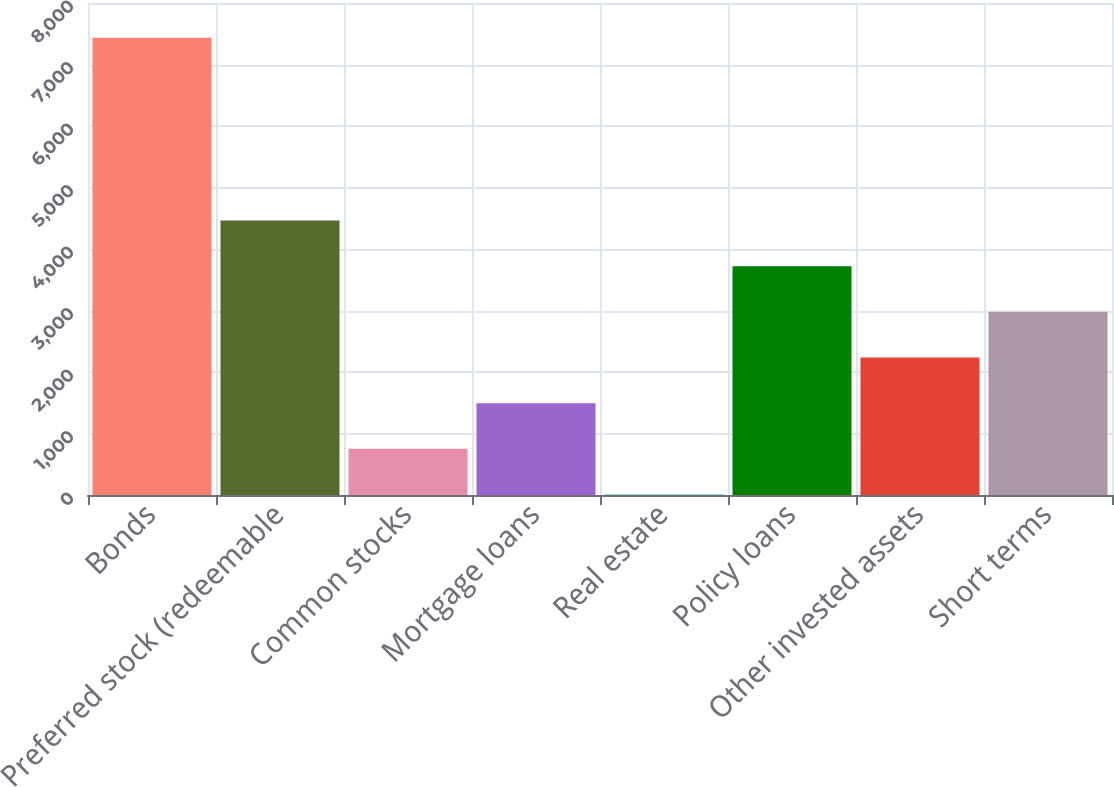<chart> <loc_0><loc_0><loc_500><loc_500><bar_chart><fcel>Bonds<fcel>Preferred stock (redeemable<fcel>Common stocks<fcel>Mortgage loans<fcel>Real estate<fcel>Policy loans<fcel>Other invested assets<fcel>Short terms<nl><fcel>7435<fcel>4464.2<fcel>750.7<fcel>1493.4<fcel>8<fcel>3721.5<fcel>2236.1<fcel>2978.8<nl></chart> 